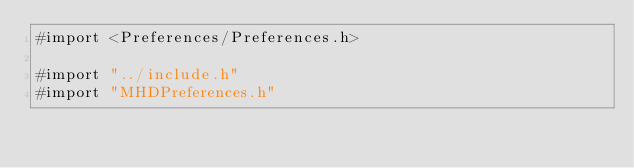Convert code to text. <code><loc_0><loc_0><loc_500><loc_500><_ObjectiveC_>#import <Preferences/Preferences.h>

#import "../include.h"
#import "MHDPreferences.h"
</code> 